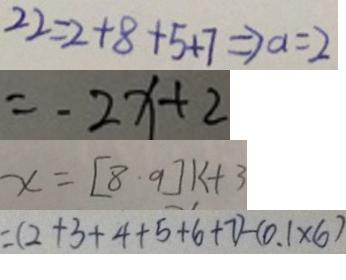Convert formula to latex. <formula><loc_0><loc_0><loc_500><loc_500>2 2 = 2 + 8 + 5 + 7 \Rightarrow a = 2 
 = - 2 x + 2 
 x = [ 8 \cdot 9 ] k + 3 
 = ( 2 + 3 + 4 + 5 + 6 + 7 ) - ( 0 . 1 \times 6 )</formula> 